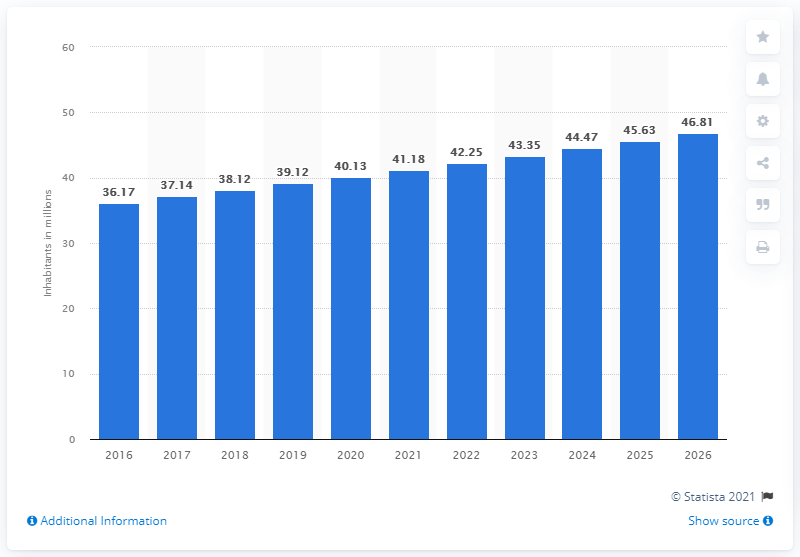What year does the graph predict Iraq will have the highest population growth? Based on the graph, the highest population growth is projected between 2025 and 2026, when the population is expected to increase from 45.63 million to 46.81 million. 